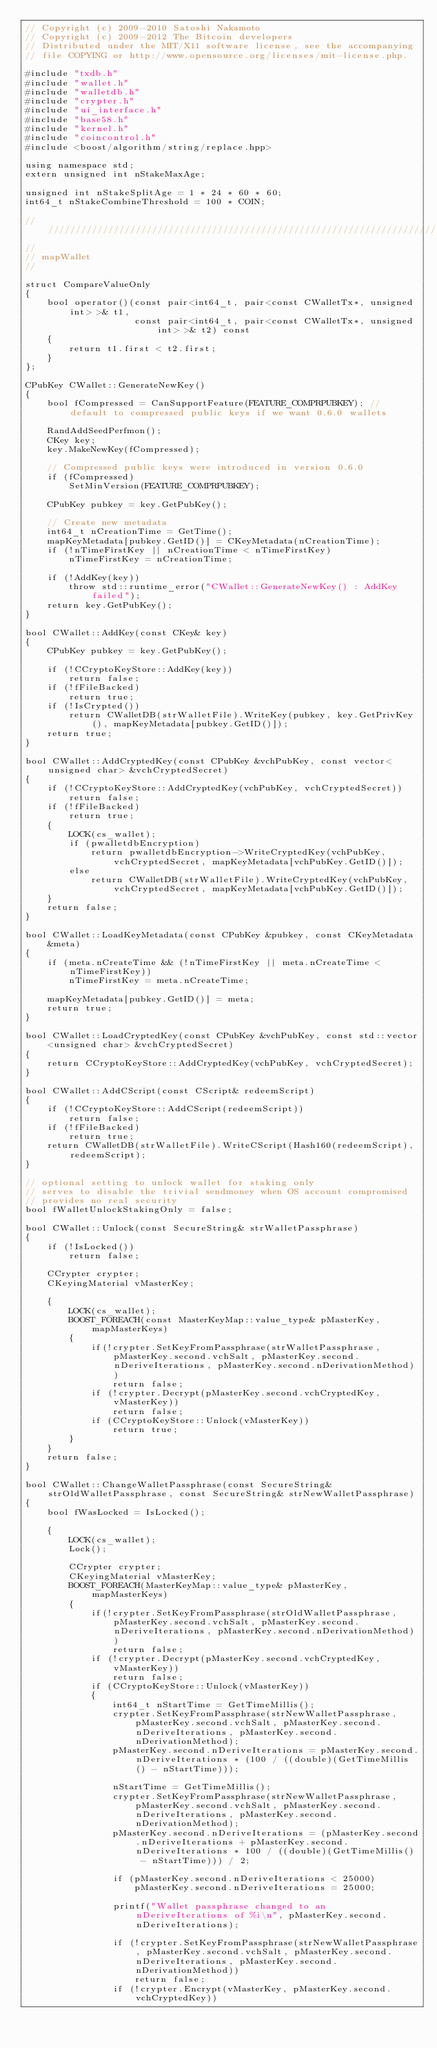<code> <loc_0><loc_0><loc_500><loc_500><_C++_>// Copyright (c) 2009-2010 Satoshi Nakamoto
// Copyright (c) 2009-2012 The Bitcoin developers
// Distributed under the MIT/X11 software license, see the accompanying
// file COPYING or http://www.opensource.org/licenses/mit-license.php.

#include "txdb.h"
#include "wallet.h"
#include "walletdb.h"
#include "crypter.h"
#include "ui_interface.h"
#include "base58.h"
#include "kernel.h"
#include "coincontrol.h"
#include <boost/algorithm/string/replace.hpp>

using namespace std;
extern unsigned int nStakeMaxAge;

unsigned int nStakeSplitAge = 1 * 24 * 60 * 60;
int64_t nStakeCombineThreshold = 100 * COIN;

//////////////////////////////////////////////////////////////////////////////
//
// mapWallet
//

struct CompareValueOnly
{
    bool operator()(const pair<int64_t, pair<const CWalletTx*, unsigned int> >& t1,
                    const pair<int64_t, pair<const CWalletTx*, unsigned int> >& t2) const
    {
        return t1.first < t2.first;
    }
};

CPubKey CWallet::GenerateNewKey()
{
    bool fCompressed = CanSupportFeature(FEATURE_COMPRPUBKEY); // default to compressed public keys if we want 0.6.0 wallets

    RandAddSeedPerfmon();
    CKey key;
    key.MakeNewKey(fCompressed);

    // Compressed public keys were introduced in version 0.6.0
    if (fCompressed)
        SetMinVersion(FEATURE_COMPRPUBKEY);

    CPubKey pubkey = key.GetPubKey();

    // Create new metadata
    int64_t nCreationTime = GetTime();
    mapKeyMetadata[pubkey.GetID()] = CKeyMetadata(nCreationTime);
    if (!nTimeFirstKey || nCreationTime < nTimeFirstKey)
        nTimeFirstKey = nCreationTime;

    if (!AddKey(key))
        throw std::runtime_error("CWallet::GenerateNewKey() : AddKey failed");
    return key.GetPubKey();
}

bool CWallet::AddKey(const CKey& key)
{
    CPubKey pubkey = key.GetPubKey();

    if (!CCryptoKeyStore::AddKey(key))
        return false;
    if (!fFileBacked)
        return true;
    if (!IsCrypted())
        return CWalletDB(strWalletFile).WriteKey(pubkey, key.GetPrivKey(), mapKeyMetadata[pubkey.GetID()]);
    return true;
}

bool CWallet::AddCryptedKey(const CPubKey &vchPubKey, const vector<unsigned char> &vchCryptedSecret)
{
    if (!CCryptoKeyStore::AddCryptedKey(vchPubKey, vchCryptedSecret))
        return false;
    if (!fFileBacked)
        return true;
    {
        LOCK(cs_wallet);
        if (pwalletdbEncryption)
            return pwalletdbEncryption->WriteCryptedKey(vchPubKey, vchCryptedSecret, mapKeyMetadata[vchPubKey.GetID()]);
        else
            return CWalletDB(strWalletFile).WriteCryptedKey(vchPubKey, vchCryptedSecret, mapKeyMetadata[vchPubKey.GetID()]);
    }
    return false;
}

bool CWallet::LoadKeyMetadata(const CPubKey &pubkey, const CKeyMetadata &meta)
{
    if (meta.nCreateTime && (!nTimeFirstKey || meta.nCreateTime < nTimeFirstKey))
        nTimeFirstKey = meta.nCreateTime;

    mapKeyMetadata[pubkey.GetID()] = meta;
    return true;
}

bool CWallet::LoadCryptedKey(const CPubKey &vchPubKey, const std::vector<unsigned char> &vchCryptedSecret)
{
    return CCryptoKeyStore::AddCryptedKey(vchPubKey, vchCryptedSecret);
}

bool CWallet::AddCScript(const CScript& redeemScript)
{
    if (!CCryptoKeyStore::AddCScript(redeemScript))
        return false;
    if (!fFileBacked)
        return true;
    return CWalletDB(strWalletFile).WriteCScript(Hash160(redeemScript), redeemScript);
}

// optional setting to unlock wallet for staking only
// serves to disable the trivial sendmoney when OS account compromised
// provides no real security
bool fWalletUnlockStakingOnly = false;

bool CWallet::Unlock(const SecureString& strWalletPassphrase)
{
    if (!IsLocked())
        return false;

    CCrypter crypter;
    CKeyingMaterial vMasterKey;

    {
        LOCK(cs_wallet);
        BOOST_FOREACH(const MasterKeyMap::value_type& pMasterKey, mapMasterKeys)
        {
            if(!crypter.SetKeyFromPassphrase(strWalletPassphrase, pMasterKey.second.vchSalt, pMasterKey.second.nDeriveIterations, pMasterKey.second.nDerivationMethod))
                return false;
            if (!crypter.Decrypt(pMasterKey.second.vchCryptedKey, vMasterKey))
                return false;
            if (CCryptoKeyStore::Unlock(vMasterKey))
                return true;
        }
    }
    return false;
}

bool CWallet::ChangeWalletPassphrase(const SecureString& strOldWalletPassphrase, const SecureString& strNewWalletPassphrase)
{
    bool fWasLocked = IsLocked();

    {
        LOCK(cs_wallet);
        Lock();

        CCrypter crypter;
        CKeyingMaterial vMasterKey;
        BOOST_FOREACH(MasterKeyMap::value_type& pMasterKey, mapMasterKeys)
        {
            if(!crypter.SetKeyFromPassphrase(strOldWalletPassphrase, pMasterKey.second.vchSalt, pMasterKey.second.nDeriveIterations, pMasterKey.second.nDerivationMethod))
                return false;
            if (!crypter.Decrypt(pMasterKey.second.vchCryptedKey, vMasterKey))
                return false;
            if (CCryptoKeyStore::Unlock(vMasterKey))
            {
                int64_t nStartTime = GetTimeMillis();
                crypter.SetKeyFromPassphrase(strNewWalletPassphrase, pMasterKey.second.vchSalt, pMasterKey.second.nDeriveIterations, pMasterKey.second.nDerivationMethod);
                pMasterKey.second.nDeriveIterations = pMasterKey.second.nDeriveIterations * (100 / ((double)(GetTimeMillis() - nStartTime)));

                nStartTime = GetTimeMillis();
                crypter.SetKeyFromPassphrase(strNewWalletPassphrase, pMasterKey.second.vchSalt, pMasterKey.second.nDeriveIterations, pMasterKey.second.nDerivationMethod);
                pMasterKey.second.nDeriveIterations = (pMasterKey.second.nDeriveIterations + pMasterKey.second.nDeriveIterations * 100 / ((double)(GetTimeMillis() - nStartTime))) / 2;

                if (pMasterKey.second.nDeriveIterations < 25000)
                    pMasterKey.second.nDeriveIterations = 25000;

                printf("Wallet passphrase changed to an nDeriveIterations of %i\n", pMasterKey.second.nDeriveIterations);

                if (!crypter.SetKeyFromPassphrase(strNewWalletPassphrase, pMasterKey.second.vchSalt, pMasterKey.second.nDeriveIterations, pMasterKey.second.nDerivationMethod))
                    return false;
                if (!crypter.Encrypt(vMasterKey, pMasterKey.second.vchCryptedKey))</code> 